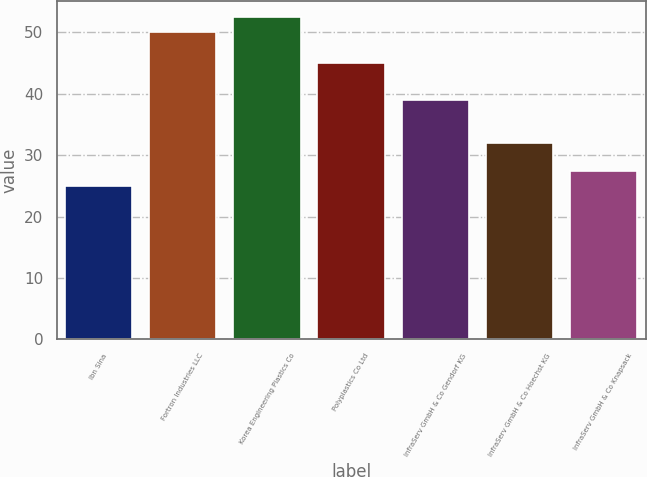Convert chart to OTSL. <chart><loc_0><loc_0><loc_500><loc_500><bar_chart><fcel>Ibn Sina<fcel>Fortron Industries LLC<fcel>Korea Engineering Plastics Co<fcel>Polyplastics Co Ltd<fcel>InfraServ GmbH & Co Gendorf KG<fcel>InfraServ GmbH & Co Hoechst KG<fcel>InfraServ GmbH & Co Knapsack<nl><fcel>25<fcel>50<fcel>52.5<fcel>45<fcel>39<fcel>32<fcel>27.5<nl></chart> 